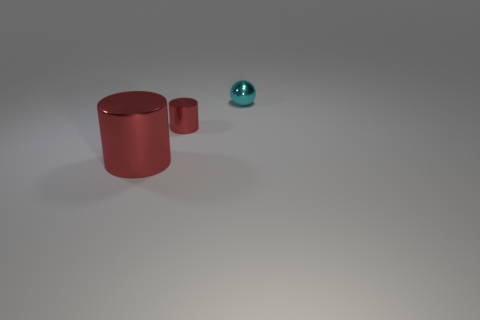Add 2 small cyan spheres. How many objects exist? 5 Subtract all cylinders. How many objects are left? 1 Subtract all small cyan shiny spheres. Subtract all big metal cylinders. How many objects are left? 1 Add 3 big metallic objects. How many big metallic objects are left? 4 Add 2 tiny red cylinders. How many tiny red cylinders exist? 3 Subtract 0 brown cylinders. How many objects are left? 3 